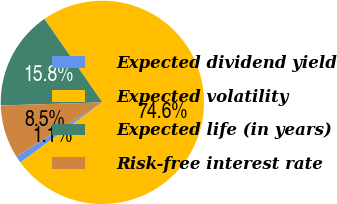Convert chart. <chart><loc_0><loc_0><loc_500><loc_500><pie_chart><fcel>Expected dividend yield<fcel>Expected volatility<fcel>Expected life (in years)<fcel>Risk-free interest rate<nl><fcel>1.12%<fcel>74.59%<fcel>15.82%<fcel>8.47%<nl></chart> 